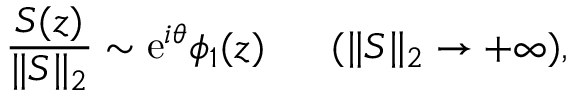<formula> <loc_0><loc_0><loc_500><loc_500>\frac { S ( z ) } { \| S \| _ { 2 } } \sim e ^ { i \theta } \phi _ { 1 } ( z ) \quad \ ( \| S \| _ { 2 } \to + \infty ) ,</formula> 